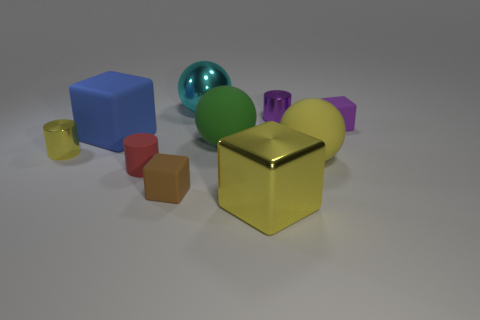What size is the sphere that is the same color as the large metal cube?
Give a very brief answer. Large. Are there any other metallic blocks of the same size as the shiny block?
Make the answer very short. No. There is a small metal cylinder that is to the left of the big yellow object that is in front of the yellow rubber sphere; are there any yellow cylinders that are behind it?
Ensure brevity in your answer.  No. Is the color of the shiny ball the same as the tiny rubber cube right of the large green matte sphere?
Offer a very short reply. No. There is a tiny cylinder that is behind the rubber ball to the left of the small purple object that is behind the purple rubber cube; what is it made of?
Make the answer very short. Metal. What shape is the yellow thing to the left of the small red rubber cylinder?
Your answer should be very brief. Cylinder. The green object that is the same material as the tiny brown cube is what size?
Give a very brief answer. Large. How many matte things are the same shape as the big yellow metal thing?
Keep it short and to the point. 3. Does the large object that is left of the large cyan metal ball have the same color as the big metallic block?
Ensure brevity in your answer.  No. There is a red matte cylinder that is on the right side of the big rubber object on the left side of the tiny brown thing; how many small purple metal objects are behind it?
Your answer should be compact. 1. 